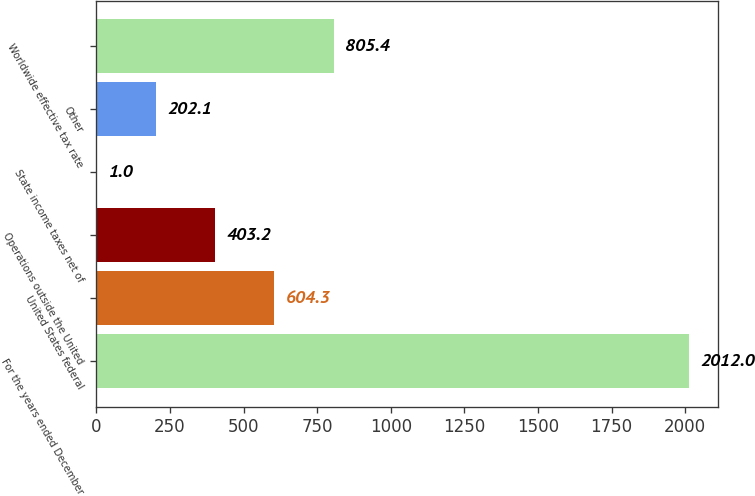<chart> <loc_0><loc_0><loc_500><loc_500><bar_chart><fcel>For the years ended December<fcel>United States federal<fcel>Operations outside the United<fcel>State income taxes net of<fcel>Other<fcel>Worldwide effective tax rate<nl><fcel>2012<fcel>604.3<fcel>403.2<fcel>1<fcel>202.1<fcel>805.4<nl></chart> 